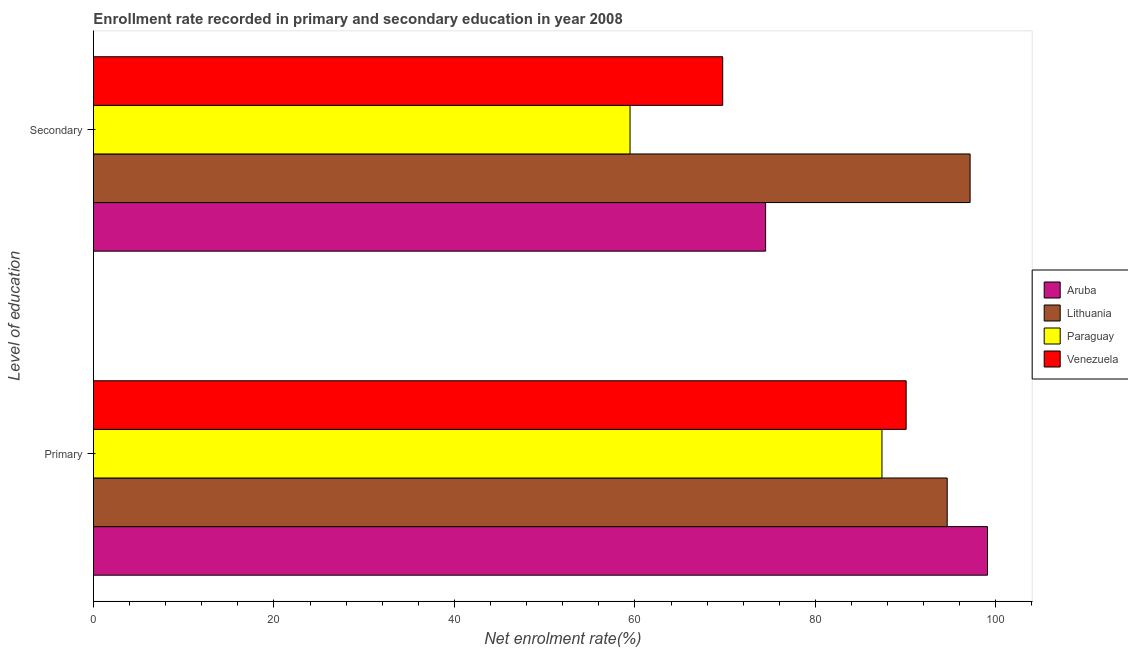How many different coloured bars are there?
Your response must be concise. 4. How many groups of bars are there?
Ensure brevity in your answer.  2. Are the number of bars per tick equal to the number of legend labels?
Offer a very short reply. Yes. Are the number of bars on each tick of the Y-axis equal?
Provide a succinct answer. Yes. What is the label of the 2nd group of bars from the top?
Provide a succinct answer. Primary. What is the enrollment rate in secondary education in Venezuela?
Keep it short and to the point. 69.73. Across all countries, what is the maximum enrollment rate in secondary education?
Give a very brief answer. 97.15. Across all countries, what is the minimum enrollment rate in secondary education?
Your answer should be compact. 59.46. In which country was the enrollment rate in secondary education maximum?
Your response must be concise. Lithuania. In which country was the enrollment rate in primary education minimum?
Your response must be concise. Paraguay. What is the total enrollment rate in primary education in the graph?
Make the answer very short. 371.11. What is the difference between the enrollment rate in secondary education in Lithuania and that in Paraguay?
Ensure brevity in your answer.  37.68. What is the difference between the enrollment rate in secondary education in Aruba and the enrollment rate in primary education in Venezuela?
Your answer should be compact. -15.58. What is the average enrollment rate in primary education per country?
Give a very brief answer. 92.78. What is the difference between the enrollment rate in secondary education and enrollment rate in primary education in Lithuania?
Make the answer very short. 2.54. In how many countries, is the enrollment rate in primary education greater than 8 %?
Keep it short and to the point. 4. What is the ratio of the enrollment rate in primary education in Venezuela to that in Lithuania?
Make the answer very short. 0.95. What does the 4th bar from the top in Secondary represents?
Your answer should be very brief. Aruba. What does the 1st bar from the bottom in Secondary represents?
Your response must be concise. Aruba. Are all the bars in the graph horizontal?
Offer a terse response. Yes. Where does the legend appear in the graph?
Offer a very short reply. Center right. How many legend labels are there?
Offer a very short reply. 4. What is the title of the graph?
Provide a succinct answer. Enrollment rate recorded in primary and secondary education in year 2008. What is the label or title of the X-axis?
Keep it short and to the point. Net enrolment rate(%). What is the label or title of the Y-axis?
Offer a very short reply. Level of education. What is the Net enrolment rate(%) of Aruba in Primary?
Ensure brevity in your answer.  99.07. What is the Net enrolment rate(%) in Lithuania in Primary?
Keep it short and to the point. 94.61. What is the Net enrolment rate(%) in Paraguay in Primary?
Give a very brief answer. 87.38. What is the Net enrolment rate(%) in Venezuela in Primary?
Offer a very short reply. 90.06. What is the Net enrolment rate(%) in Aruba in Secondary?
Keep it short and to the point. 74.48. What is the Net enrolment rate(%) of Lithuania in Secondary?
Make the answer very short. 97.15. What is the Net enrolment rate(%) in Paraguay in Secondary?
Ensure brevity in your answer.  59.46. What is the Net enrolment rate(%) of Venezuela in Secondary?
Give a very brief answer. 69.73. Across all Level of education, what is the maximum Net enrolment rate(%) of Aruba?
Give a very brief answer. 99.07. Across all Level of education, what is the maximum Net enrolment rate(%) of Lithuania?
Give a very brief answer. 97.15. Across all Level of education, what is the maximum Net enrolment rate(%) of Paraguay?
Your response must be concise. 87.38. Across all Level of education, what is the maximum Net enrolment rate(%) of Venezuela?
Offer a very short reply. 90.06. Across all Level of education, what is the minimum Net enrolment rate(%) in Aruba?
Provide a succinct answer. 74.48. Across all Level of education, what is the minimum Net enrolment rate(%) of Lithuania?
Your answer should be compact. 94.61. Across all Level of education, what is the minimum Net enrolment rate(%) in Paraguay?
Offer a terse response. 59.46. Across all Level of education, what is the minimum Net enrolment rate(%) in Venezuela?
Give a very brief answer. 69.73. What is the total Net enrolment rate(%) in Aruba in the graph?
Offer a very short reply. 173.55. What is the total Net enrolment rate(%) of Lithuania in the graph?
Provide a short and direct response. 191.75. What is the total Net enrolment rate(%) of Paraguay in the graph?
Keep it short and to the point. 146.84. What is the total Net enrolment rate(%) of Venezuela in the graph?
Make the answer very short. 159.79. What is the difference between the Net enrolment rate(%) of Aruba in Primary and that in Secondary?
Offer a very short reply. 24.59. What is the difference between the Net enrolment rate(%) in Lithuania in Primary and that in Secondary?
Your answer should be compact. -2.54. What is the difference between the Net enrolment rate(%) of Paraguay in Primary and that in Secondary?
Ensure brevity in your answer.  27.91. What is the difference between the Net enrolment rate(%) of Venezuela in Primary and that in Secondary?
Provide a succinct answer. 20.33. What is the difference between the Net enrolment rate(%) in Aruba in Primary and the Net enrolment rate(%) in Lithuania in Secondary?
Offer a terse response. 1.92. What is the difference between the Net enrolment rate(%) of Aruba in Primary and the Net enrolment rate(%) of Paraguay in Secondary?
Ensure brevity in your answer.  39.61. What is the difference between the Net enrolment rate(%) of Aruba in Primary and the Net enrolment rate(%) of Venezuela in Secondary?
Ensure brevity in your answer.  29.34. What is the difference between the Net enrolment rate(%) in Lithuania in Primary and the Net enrolment rate(%) in Paraguay in Secondary?
Provide a short and direct response. 35.14. What is the difference between the Net enrolment rate(%) of Lithuania in Primary and the Net enrolment rate(%) of Venezuela in Secondary?
Give a very brief answer. 24.88. What is the difference between the Net enrolment rate(%) in Paraguay in Primary and the Net enrolment rate(%) in Venezuela in Secondary?
Offer a terse response. 17.65. What is the average Net enrolment rate(%) in Aruba per Level of education?
Give a very brief answer. 86.78. What is the average Net enrolment rate(%) in Lithuania per Level of education?
Your answer should be very brief. 95.88. What is the average Net enrolment rate(%) in Paraguay per Level of education?
Your answer should be compact. 73.42. What is the average Net enrolment rate(%) of Venezuela per Level of education?
Offer a terse response. 79.89. What is the difference between the Net enrolment rate(%) in Aruba and Net enrolment rate(%) in Lithuania in Primary?
Make the answer very short. 4.46. What is the difference between the Net enrolment rate(%) of Aruba and Net enrolment rate(%) of Paraguay in Primary?
Offer a very short reply. 11.69. What is the difference between the Net enrolment rate(%) of Aruba and Net enrolment rate(%) of Venezuela in Primary?
Offer a terse response. 9.01. What is the difference between the Net enrolment rate(%) of Lithuania and Net enrolment rate(%) of Paraguay in Primary?
Your answer should be very brief. 7.23. What is the difference between the Net enrolment rate(%) of Lithuania and Net enrolment rate(%) of Venezuela in Primary?
Your answer should be compact. 4.55. What is the difference between the Net enrolment rate(%) in Paraguay and Net enrolment rate(%) in Venezuela in Primary?
Offer a terse response. -2.68. What is the difference between the Net enrolment rate(%) of Aruba and Net enrolment rate(%) of Lithuania in Secondary?
Ensure brevity in your answer.  -22.66. What is the difference between the Net enrolment rate(%) in Aruba and Net enrolment rate(%) in Paraguay in Secondary?
Offer a very short reply. 15.02. What is the difference between the Net enrolment rate(%) of Aruba and Net enrolment rate(%) of Venezuela in Secondary?
Give a very brief answer. 4.75. What is the difference between the Net enrolment rate(%) in Lithuania and Net enrolment rate(%) in Paraguay in Secondary?
Provide a succinct answer. 37.68. What is the difference between the Net enrolment rate(%) of Lithuania and Net enrolment rate(%) of Venezuela in Secondary?
Give a very brief answer. 27.42. What is the difference between the Net enrolment rate(%) in Paraguay and Net enrolment rate(%) in Venezuela in Secondary?
Your answer should be compact. -10.27. What is the ratio of the Net enrolment rate(%) in Aruba in Primary to that in Secondary?
Provide a short and direct response. 1.33. What is the ratio of the Net enrolment rate(%) in Lithuania in Primary to that in Secondary?
Provide a succinct answer. 0.97. What is the ratio of the Net enrolment rate(%) of Paraguay in Primary to that in Secondary?
Your response must be concise. 1.47. What is the ratio of the Net enrolment rate(%) of Venezuela in Primary to that in Secondary?
Keep it short and to the point. 1.29. What is the difference between the highest and the second highest Net enrolment rate(%) in Aruba?
Ensure brevity in your answer.  24.59. What is the difference between the highest and the second highest Net enrolment rate(%) in Lithuania?
Keep it short and to the point. 2.54. What is the difference between the highest and the second highest Net enrolment rate(%) in Paraguay?
Provide a short and direct response. 27.91. What is the difference between the highest and the second highest Net enrolment rate(%) of Venezuela?
Your answer should be compact. 20.33. What is the difference between the highest and the lowest Net enrolment rate(%) in Aruba?
Provide a short and direct response. 24.59. What is the difference between the highest and the lowest Net enrolment rate(%) in Lithuania?
Offer a terse response. 2.54. What is the difference between the highest and the lowest Net enrolment rate(%) in Paraguay?
Offer a terse response. 27.91. What is the difference between the highest and the lowest Net enrolment rate(%) of Venezuela?
Provide a short and direct response. 20.33. 